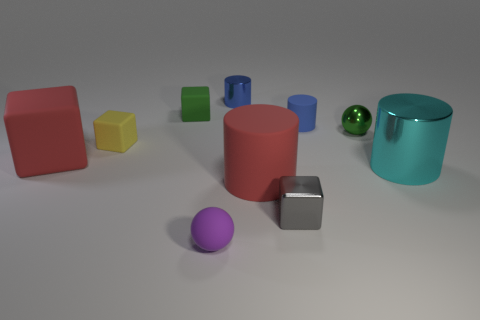Subtract all red cubes. How many blue cylinders are left? 2 Subtract all gray metallic cubes. How many cubes are left? 3 Subtract all cyan cylinders. How many cylinders are left? 3 Subtract all cylinders. How many objects are left? 6 Subtract 1 balls. How many balls are left? 1 Subtract all tiny cyan rubber balls. Subtract all tiny gray metal blocks. How many objects are left? 9 Add 3 red matte things. How many red matte things are left? 5 Add 4 green rubber cubes. How many green rubber cubes exist? 5 Subtract 0 red balls. How many objects are left? 10 Subtract all yellow spheres. Subtract all purple cylinders. How many spheres are left? 2 